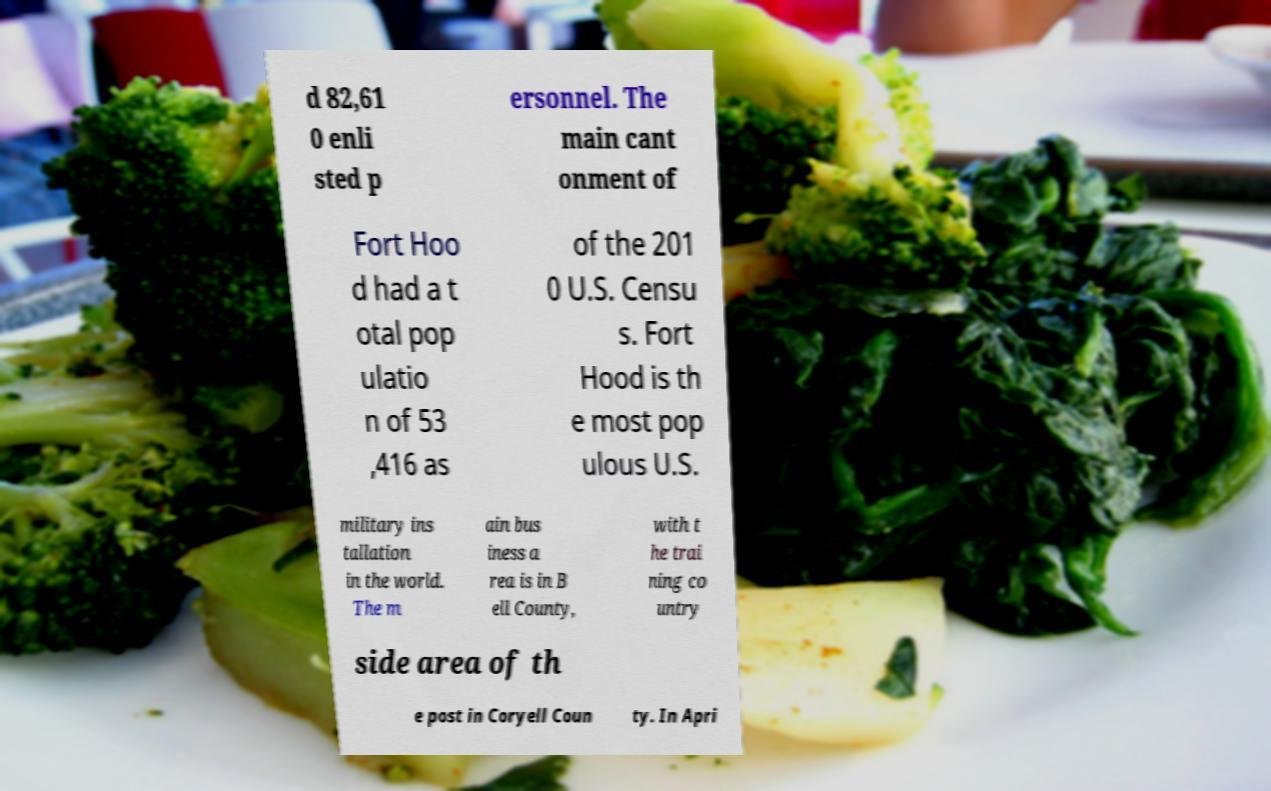Could you extract and type out the text from this image? d 82,61 0 enli sted p ersonnel. The main cant onment of Fort Hoo d had a t otal pop ulatio n of 53 ,416 as of the 201 0 U.S. Censu s. Fort Hood is th e most pop ulous U.S. military ins tallation in the world. The m ain bus iness a rea is in B ell County, with t he trai ning co untry side area of th e post in Coryell Coun ty. In Apri 